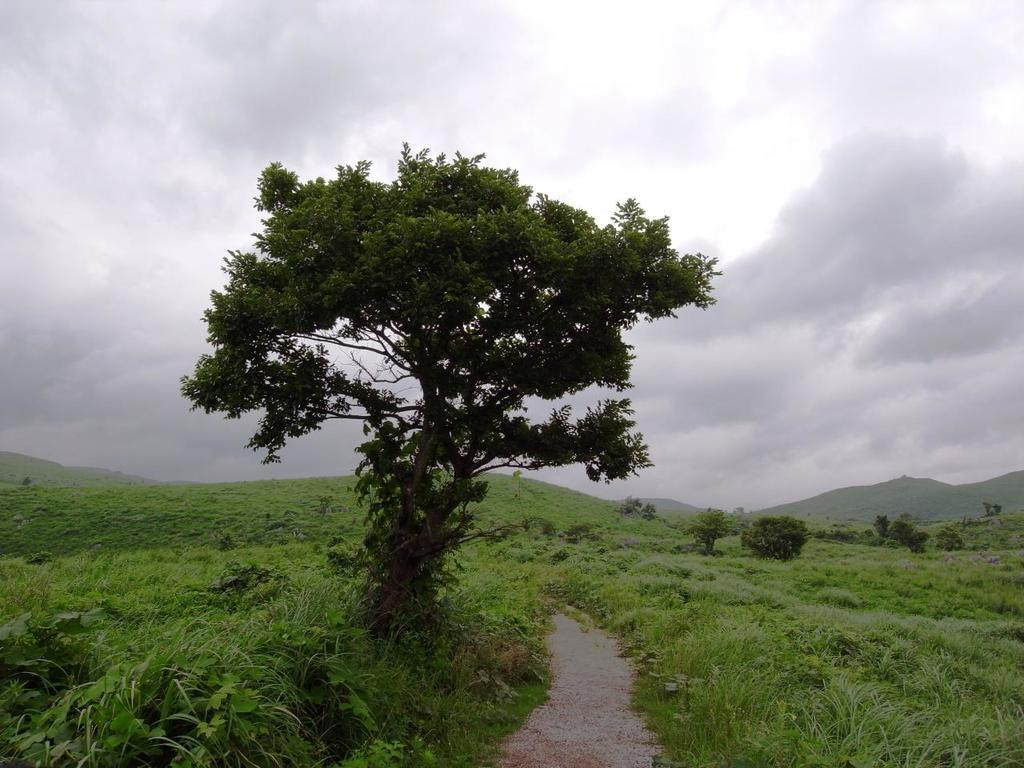Where was the picture taken? The picture was taken in a field. What can be seen in the foreground of the image? There are trees, plants, grass, and a path in the foreground of the image. What is the condition of the sky in the image? The sky is cloudy in the image. What type of zinc is being used to make apparel in the image? There is no zinc or apparel present in the image; it features a field with trees, plants, grass, a path, and a cloudy sky. Can you tell me how many bags of popcorn are visible in the image? There are no bags of popcorn present in the image. 